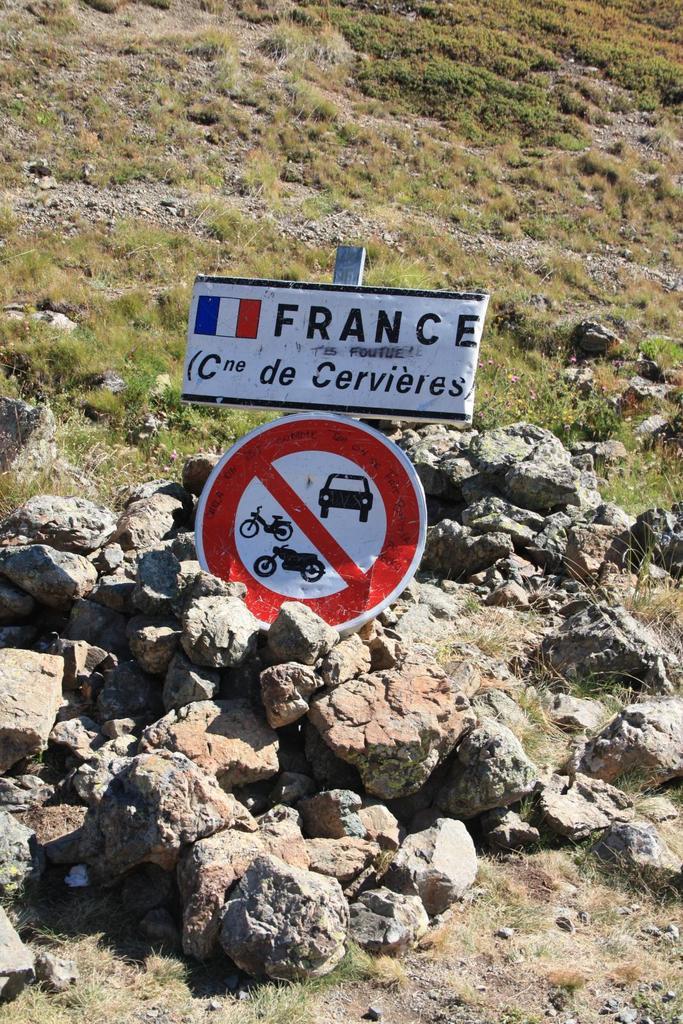Which country's flag is pictured on the sign?
Provide a succinct answer. France. 